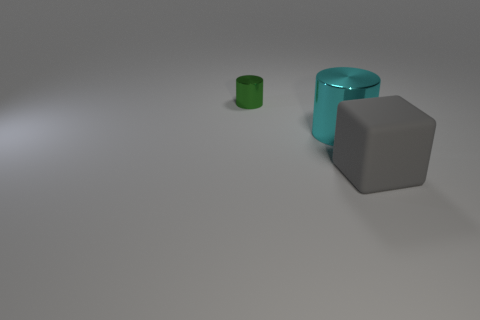Is there anything else that is the same size as the green cylinder?
Keep it short and to the point. No. Is the thing that is to the left of the big metal cylinder made of the same material as the big cyan object?
Give a very brief answer. Yes. Is there a thing that is on the right side of the cylinder that is behind the big cyan metallic object?
Make the answer very short. Yes. There is another large thing that is the same shape as the green thing; what is its material?
Offer a terse response. Metal. Are there more small cylinders that are on the left side of the matte object than tiny cylinders on the right side of the green metal thing?
Your answer should be very brief. Yes. Is the number of cyan metallic objects on the left side of the large gray object greater than the number of tiny gray things?
Keep it short and to the point. Yes. What number of other objects are there of the same color as the small object?
Provide a short and direct response. 0. Is the number of big cyan metal cylinders greater than the number of tiny cyan rubber blocks?
Give a very brief answer. Yes. What is the cube made of?
Make the answer very short. Rubber. There is a metallic cylinder that is in front of the green metal object; is its size the same as the tiny metal cylinder?
Your answer should be compact. No. 